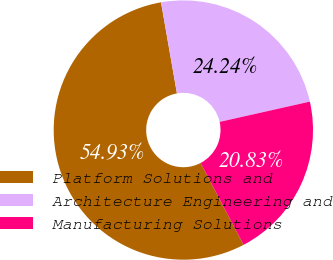Convert chart. <chart><loc_0><loc_0><loc_500><loc_500><pie_chart><fcel>Platform Solutions and<fcel>Architecture Engineering and<fcel>Manufacturing Solutions<nl><fcel>54.93%<fcel>24.24%<fcel>20.83%<nl></chart> 